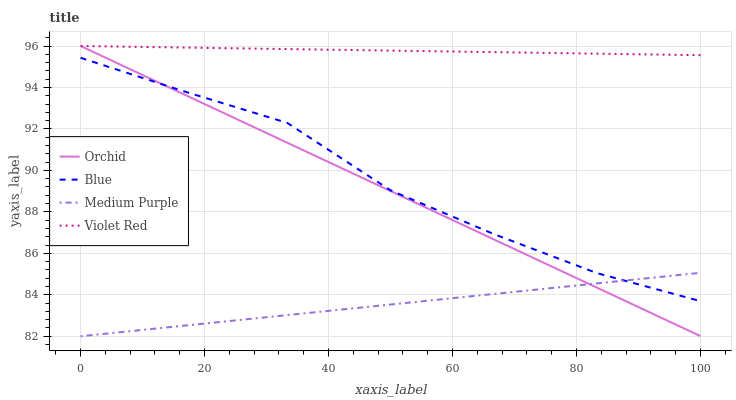Does Medium Purple have the minimum area under the curve?
Answer yes or no. Yes. Does Violet Red have the maximum area under the curve?
Answer yes or no. Yes. Does Violet Red have the minimum area under the curve?
Answer yes or no. No. Does Medium Purple have the maximum area under the curve?
Answer yes or no. No. Is Medium Purple the smoothest?
Answer yes or no. Yes. Is Blue the roughest?
Answer yes or no. Yes. Is Violet Red the smoothest?
Answer yes or no. No. Is Violet Red the roughest?
Answer yes or no. No. Does Medium Purple have the lowest value?
Answer yes or no. Yes. Does Violet Red have the lowest value?
Answer yes or no. No. Does Orchid have the highest value?
Answer yes or no. Yes. Does Medium Purple have the highest value?
Answer yes or no. No. Is Blue less than Violet Red?
Answer yes or no. Yes. Is Violet Red greater than Medium Purple?
Answer yes or no. Yes. Does Orchid intersect Blue?
Answer yes or no. Yes. Is Orchid less than Blue?
Answer yes or no. No. Is Orchid greater than Blue?
Answer yes or no. No. Does Blue intersect Violet Red?
Answer yes or no. No. 